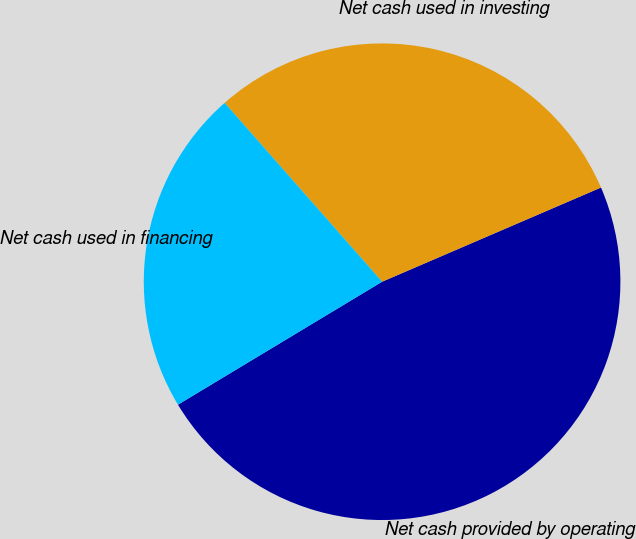Convert chart. <chart><loc_0><loc_0><loc_500><loc_500><pie_chart><fcel>Net cash provided by operating<fcel>Net cash used in investing<fcel>Net cash used in financing<nl><fcel>47.84%<fcel>30.02%<fcel>22.14%<nl></chart> 